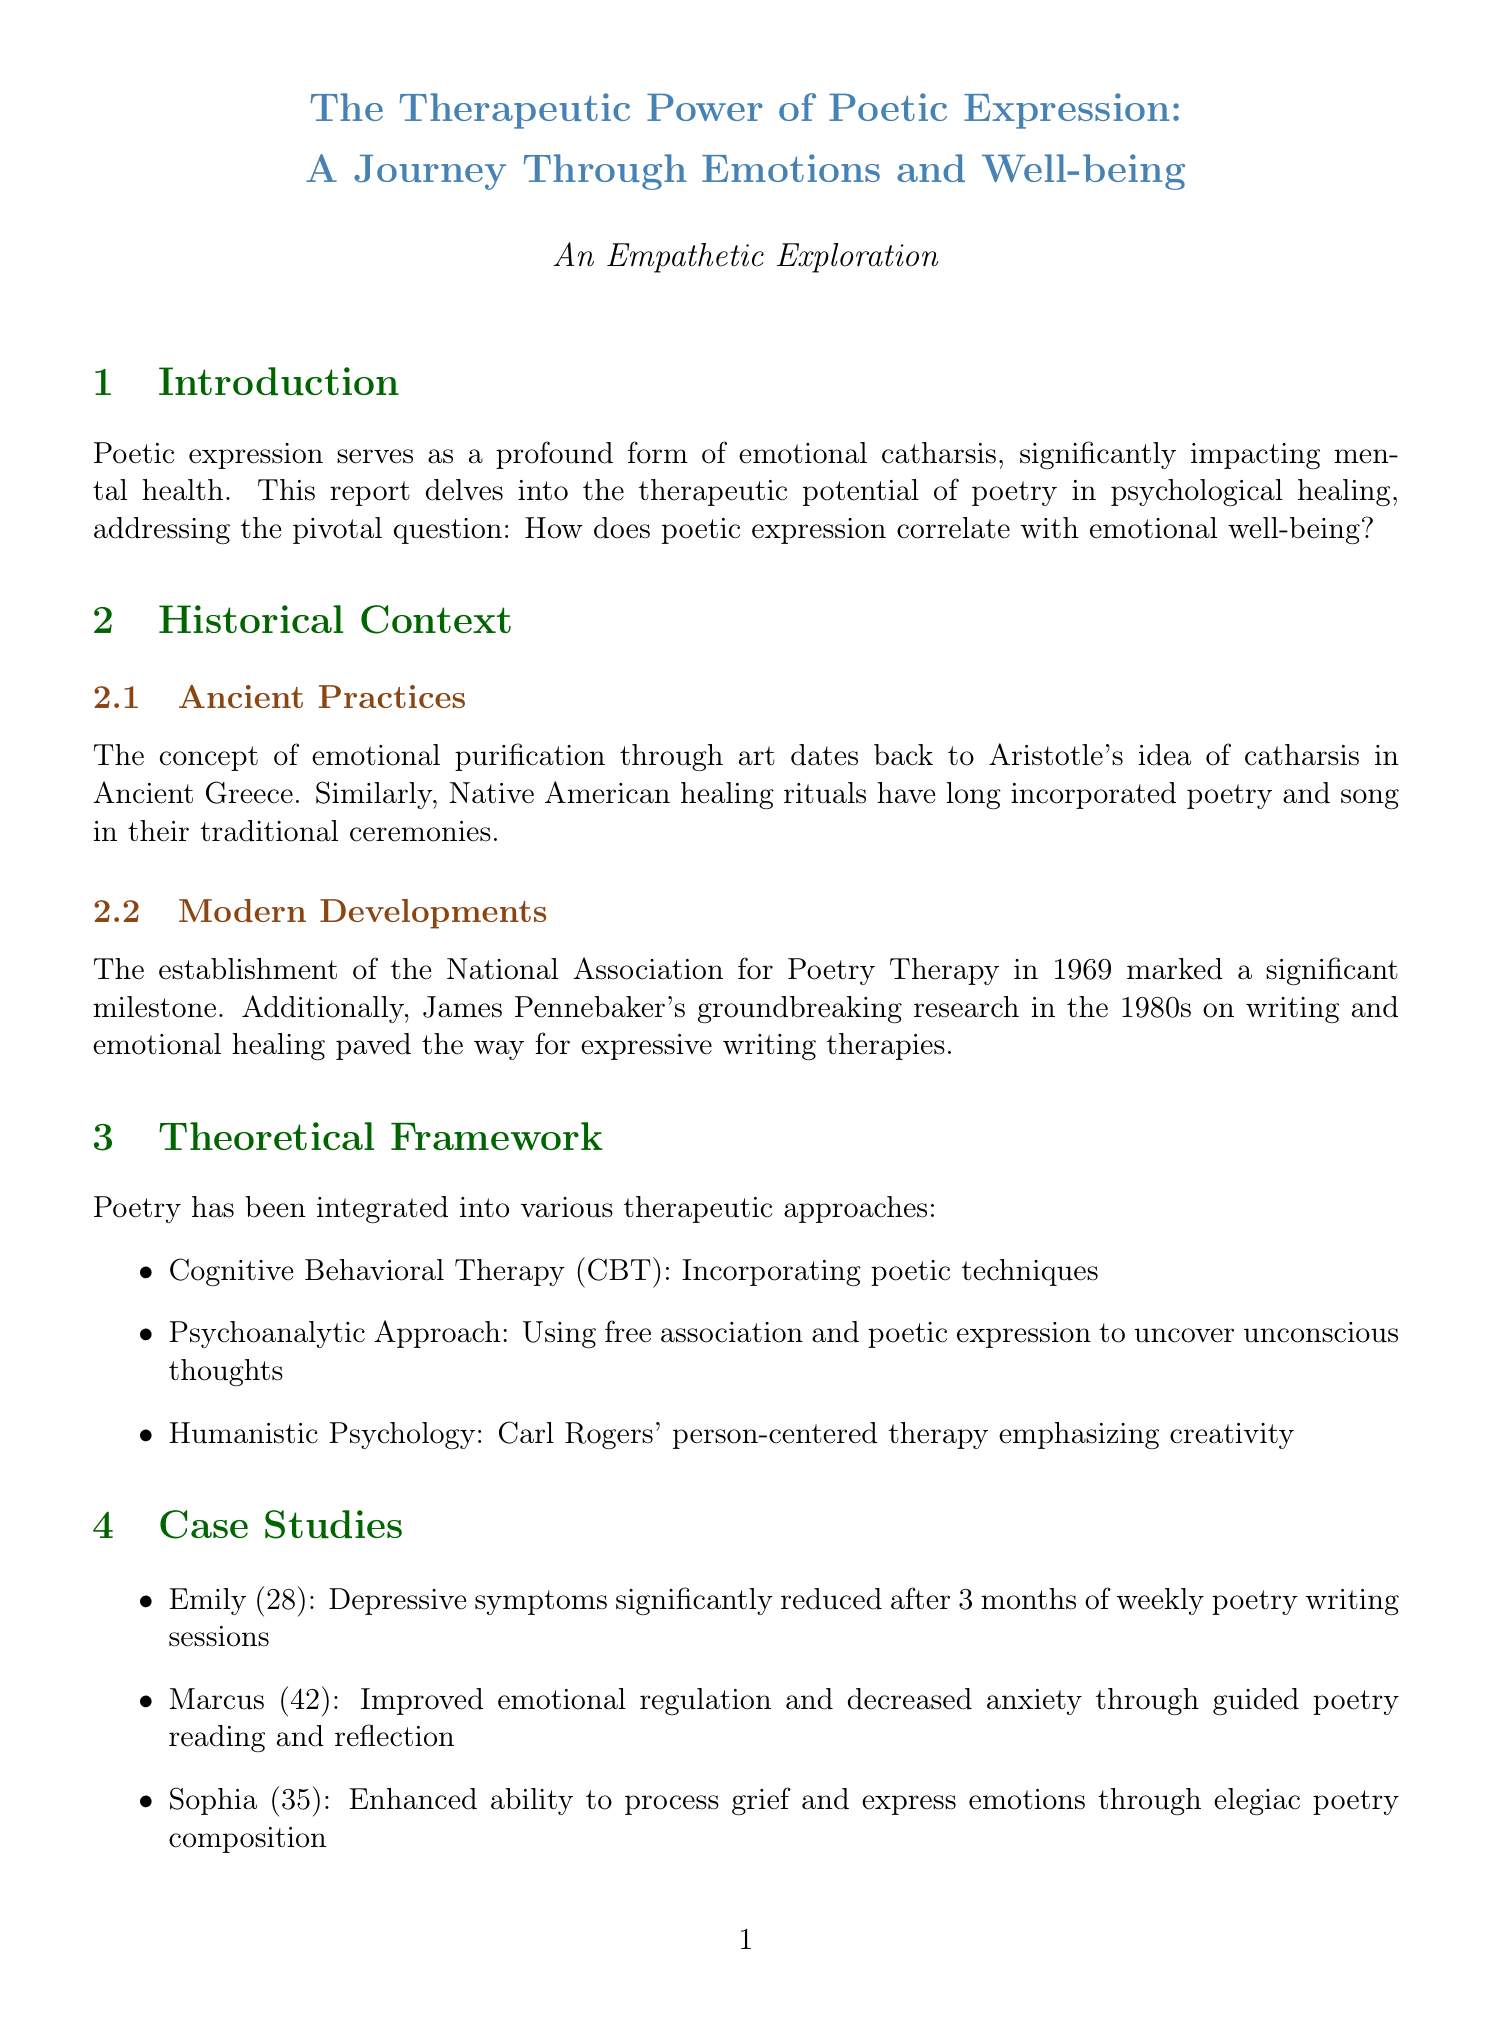What is the research question addressed in the report? The research question is highlighted in the introduction and seeks to understand the relationship between poetic expression and a specific aspect of mental health.
Answer: How does poetic expression correlate with emotional well-being? What percentage of participants reported improved emotional well-being in the meta-analysis? The document provides specific statistical findings from the meta-analysis regarding participants' reports of improvement after engaging in poetry.
Answer: 72% What therapeutic technique is used for individual therapy? The report lists specific approaches that are incorporated into individual therapy using poetry as a therapeutic tool.
Answer: Guided poetry writing exercises How long was the longitudinal study conducted? The duration of the longitudinal study is reported in the section discussing statistical evidence and findings from research.
Answer: 5 years What condition did Emily have? The document provides specific case studies detailing individuals and their mental health conditions, including Emily's case.
Answer: Depression What is the observed effect on cortisol levels after poetry writing sessions? The neuroscientific evidence section discusses the impact of poetry on neurochemical levels, including stress-related hormones.
Answer: Decreased cortisol levels What is the name of the organization established in 1969? The historical context provides information on significant milestones in poetry therapy, including the establishment of important organizations.
Answer: National Association for Poetry Therapy What was the outcome for Sophia after composing elegiac poetry? The case studies outline the interventions and resulting outcomes for individuals, including Sophia's situation regarding grief.
Answer: Enhanced ability to process loss and express emotions 